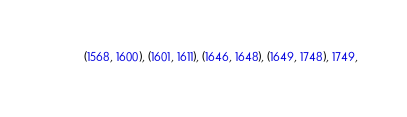Convert code to text. <code><loc_0><loc_0><loc_500><loc_500><_Python_>           (1568, 1600), (1601, 1611), (1646, 1648), (1649, 1748), 1749,</code> 